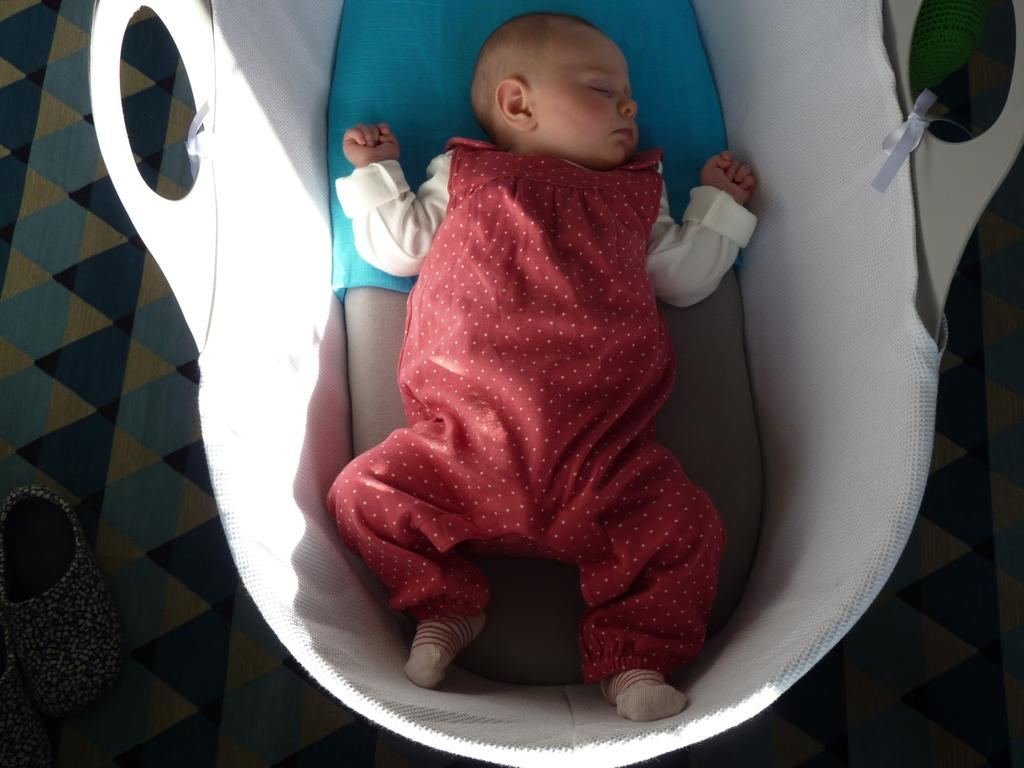What is the main subject of the image? The main subject of the image is a baby. What is the baby doing in the image? The baby is sleeping in the image. What is the baby wearing? The baby is wearing clothes in the image. What object can be seen in the image besides the baby? There is a basket in the image. What part of the room is visible in the image? The floor is visible in the image. What else can be seen in the image? There are shoes in the image. How does the baby compare to the woman in the image? There is no woman present in the image, so it is not possible to make a comparison. 